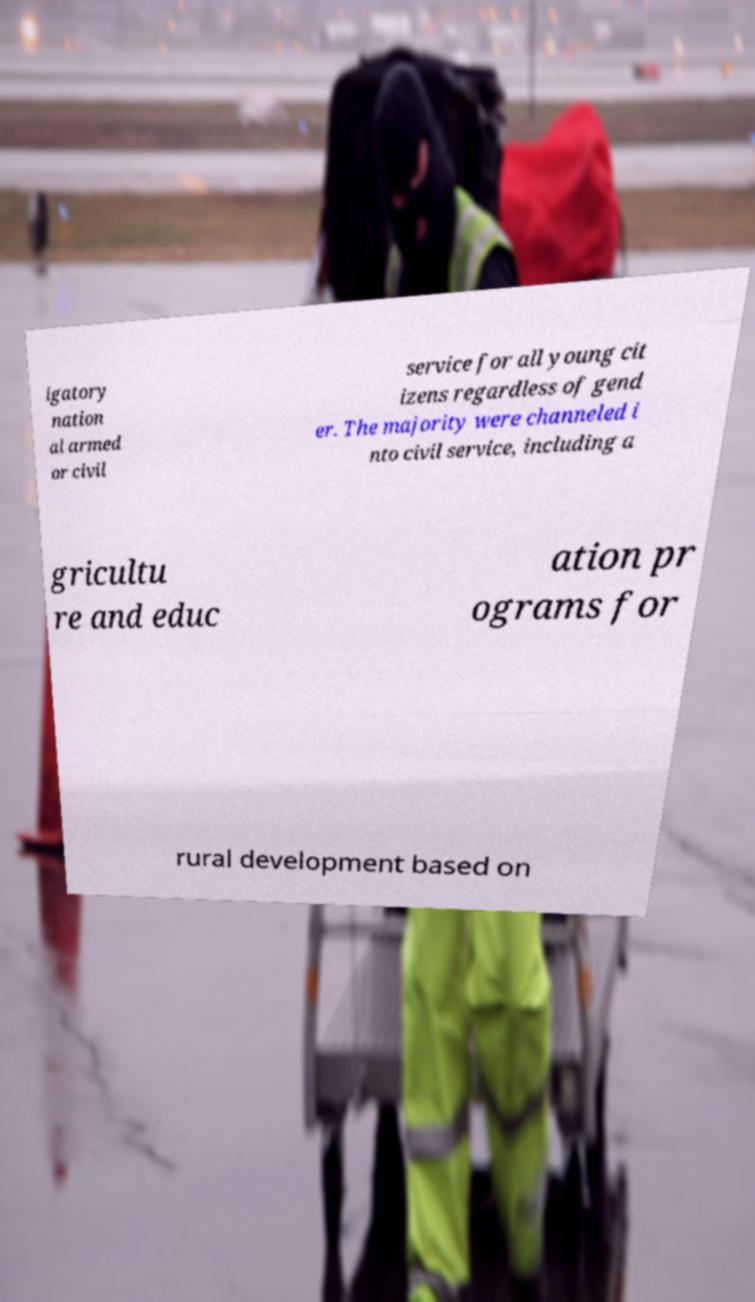For documentation purposes, I need the text within this image transcribed. Could you provide that? igatory nation al armed or civil service for all young cit izens regardless of gend er. The majority were channeled i nto civil service, including a gricultu re and educ ation pr ograms for rural development based on 